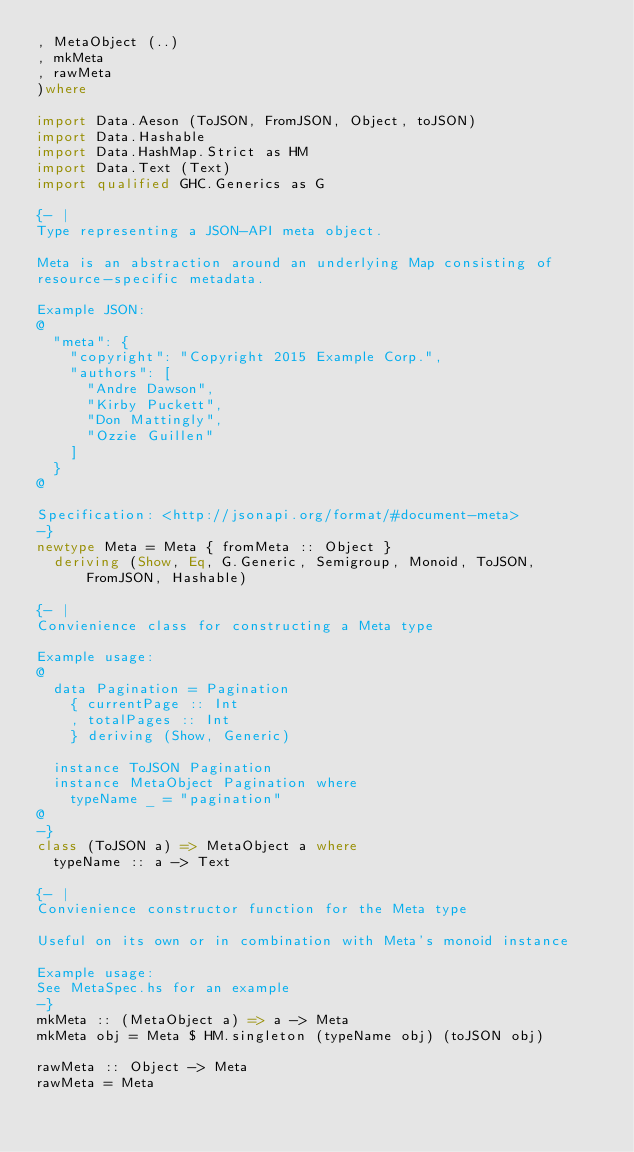Convert code to text. <code><loc_0><loc_0><loc_500><loc_500><_Haskell_>, MetaObject (..)
, mkMeta
, rawMeta
)where

import Data.Aeson (ToJSON, FromJSON, Object, toJSON)
import Data.Hashable
import Data.HashMap.Strict as HM
import Data.Text (Text)
import qualified GHC.Generics as G

{- |
Type representing a JSON-API meta object.

Meta is an abstraction around an underlying Map consisting of
resource-specific metadata.

Example JSON:
@
  "meta": {
    "copyright": "Copyright 2015 Example Corp.",
    "authors": [
      "Andre Dawson",
      "Kirby Puckett",
      "Don Mattingly",
      "Ozzie Guillen"
    ]
  }
@

Specification: <http://jsonapi.org/format/#document-meta>
-}
newtype Meta = Meta { fromMeta :: Object }
  deriving (Show, Eq, G.Generic, Semigroup, Monoid, ToJSON, FromJSON, Hashable)

{- |
Convienience class for constructing a Meta type

Example usage:
@
  data Pagination = Pagination
    { currentPage :: Int
    , totalPages :: Int
    } deriving (Show, Generic)

  instance ToJSON Pagination
  instance MetaObject Pagination where
    typeName _ = "pagination"
@
-}
class (ToJSON a) => MetaObject a where
  typeName :: a -> Text

{- |
Convienience constructor function for the Meta type

Useful on its own or in combination with Meta's monoid instance

Example usage:
See MetaSpec.hs for an example
-}
mkMeta :: (MetaObject a) => a -> Meta
mkMeta obj = Meta $ HM.singleton (typeName obj) (toJSON obj)

rawMeta :: Object -> Meta
rawMeta = Meta

</code> 